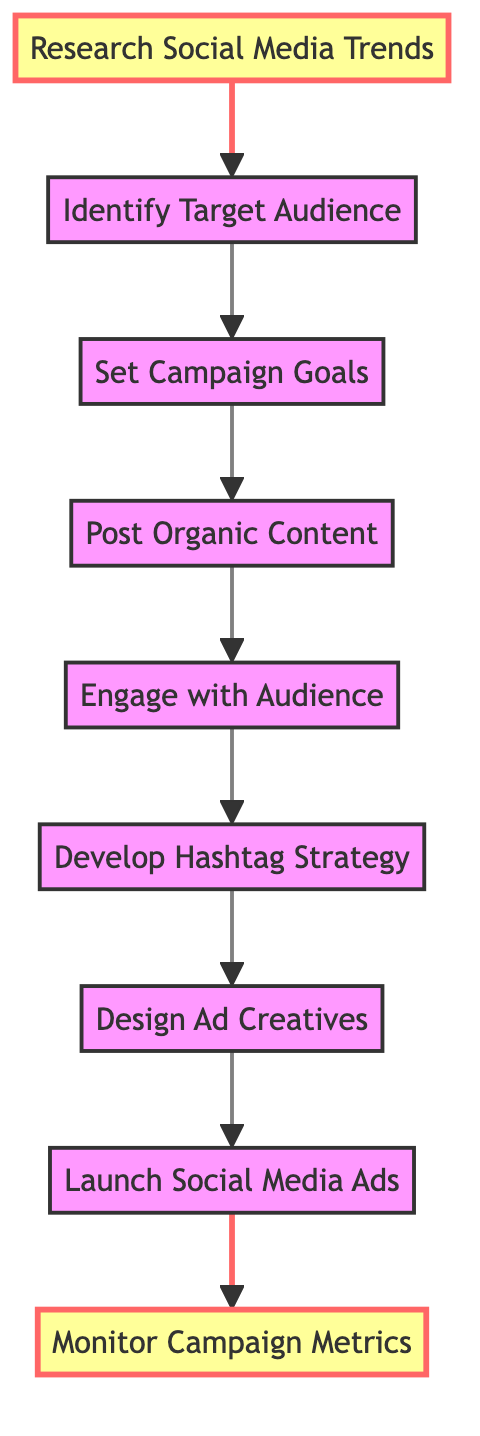What is the first step in the diagram? The diagram starts with "Research Social Media Trends," which is the topmost element in the flow.
Answer: Research Social Media Trends How many steps are there in the process? There are nine elements in the diagram, each representing a specific step in the promotion campaign.
Answer: Nine What do you do after setting campaign goals? After setting campaign goals, the next step is to "Post Organic Content."
Answer: Post Organic Content Which step involves engagement with the audience? The step that involves connecting with fans is "Engage with Audience."
Answer: Engage with Audience What comes before designing ad creatives? Before designing ad creatives, the necessary step is to "Develop Hashtag Strategy."
Answer: Develop Hashtag Strategy What metrics do you monitor after launching social media ads? After launching ads, the metrics to monitor include likes, shares, comments, and follows.
Answer: Monitor Campaign Metrics Which two steps are highlighted in the diagram? The highlighted steps are "Research Social Media Trends" and "Monitor Campaign Metrics," indicating their importance in the flow.
Answer: Research Social Media Trends and Monitor Campaign Metrics What is the last step in the promotion campaign process? The final step in the process is "Monitor Campaign Metrics."
Answer: Monitor Campaign Metrics Which step is directly linked to identifying the target audience? The step directly following "Identify Target Audience" is "Set Campaign Goals."
Answer: Set Campaign Goals 